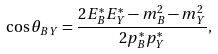<formula> <loc_0><loc_0><loc_500><loc_500>\cos \theta _ { B Y } = \frac { 2 E ^ { * } _ { B } E ^ { * } _ { Y } - m ^ { 2 } _ { B } - m ^ { 2 } _ { Y } } { 2 p ^ { * } _ { B } p ^ { * } _ { Y } } ,</formula> 